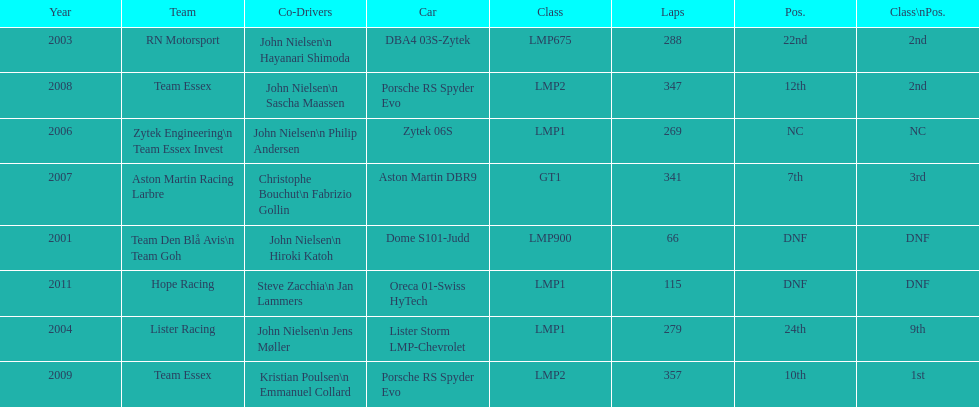Would you be able to parse every entry in this table? {'header': ['Year', 'Team', 'Co-Drivers', 'Car', 'Class', 'Laps', 'Pos.', 'Class\\nPos.'], 'rows': [['2003', 'RN Motorsport', 'John Nielsen\\n Hayanari Shimoda', 'DBA4 03S-Zytek', 'LMP675', '288', '22nd', '2nd'], ['2008', 'Team Essex', 'John Nielsen\\n Sascha Maassen', 'Porsche RS Spyder Evo', 'LMP2', '347', '12th', '2nd'], ['2006', 'Zytek Engineering\\n Team Essex Invest', 'John Nielsen\\n Philip Andersen', 'Zytek 06S', 'LMP1', '269', 'NC', 'NC'], ['2007', 'Aston Martin Racing Larbre', 'Christophe Bouchut\\n Fabrizio Gollin', 'Aston Martin DBR9', 'GT1', '341', '7th', '3rd'], ['2001', 'Team Den Blå Avis\\n Team Goh', 'John Nielsen\\n Hiroki Katoh', 'Dome S101-Judd', 'LMP900', '66', 'DNF', 'DNF'], ['2011', 'Hope Racing', 'Steve Zacchia\\n Jan Lammers', 'Oreca 01-Swiss HyTech', 'LMP1', '115', 'DNF', 'DNF'], ['2004', 'Lister Racing', 'John Nielsen\\n Jens Møller', 'Lister Storm LMP-Chevrolet', 'LMP1', '279', '24th', '9th'], ['2009', 'Team Essex', 'Kristian Poulsen\\n Emmanuel Collard', 'Porsche RS Spyder Evo', 'LMP2', '357', '10th', '1st']]} What is the amount races that were competed in? 8. 